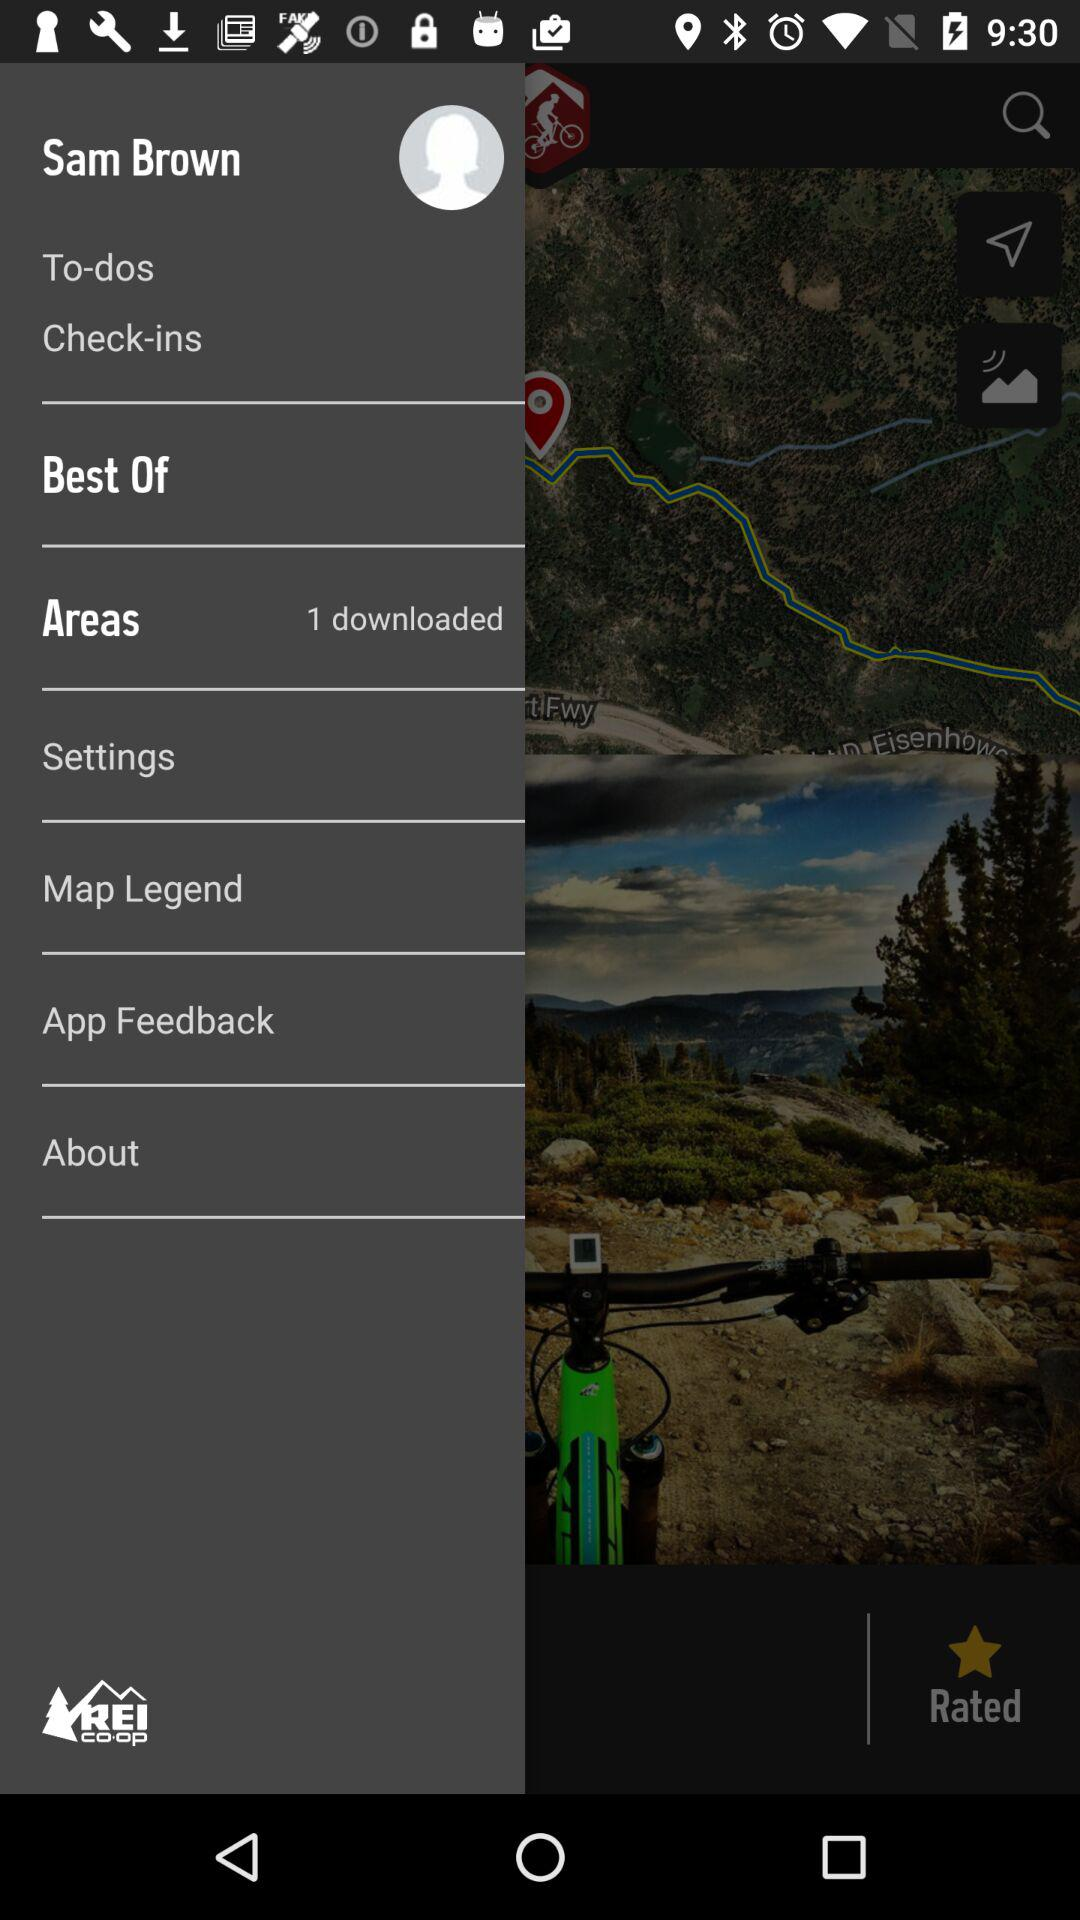How many items are in "To-dos"?
When the provided information is insufficient, respond with <no answer>. <no answer> 